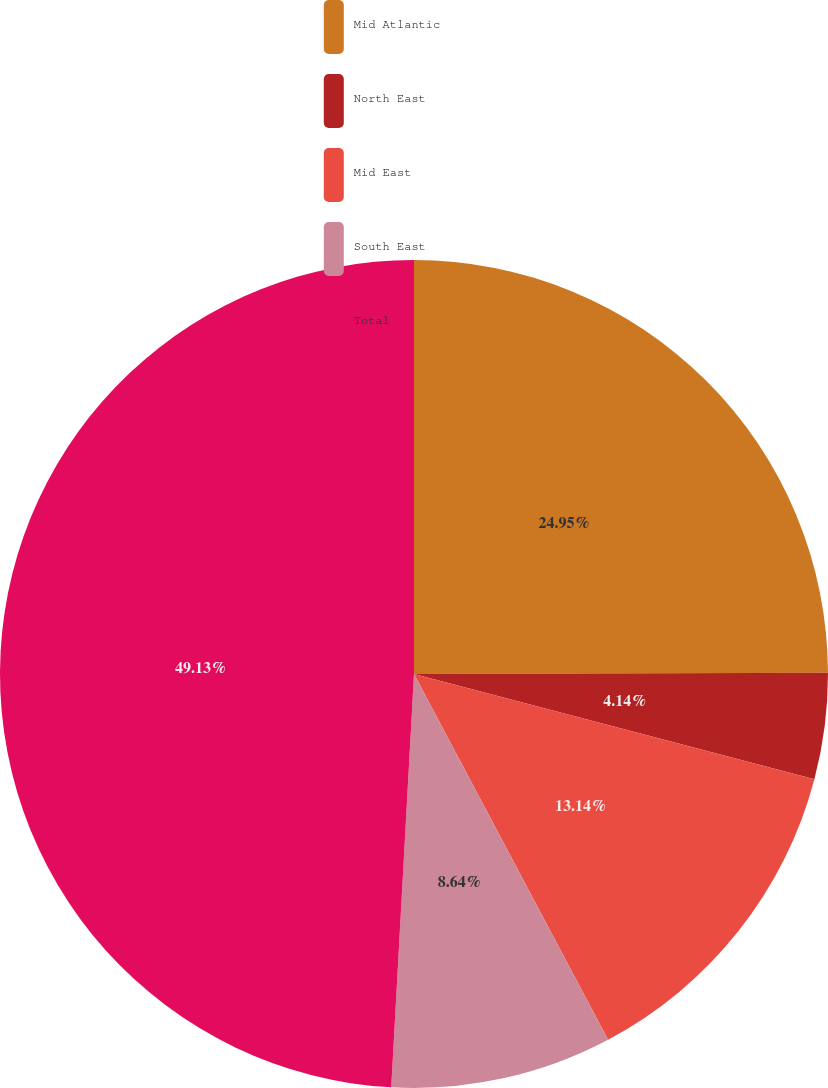Convert chart to OTSL. <chart><loc_0><loc_0><loc_500><loc_500><pie_chart><fcel>Mid Atlantic<fcel>North East<fcel>Mid East<fcel>South East<fcel>Total<nl><fcel>24.95%<fcel>4.14%<fcel>13.14%<fcel>8.64%<fcel>49.12%<nl></chart> 